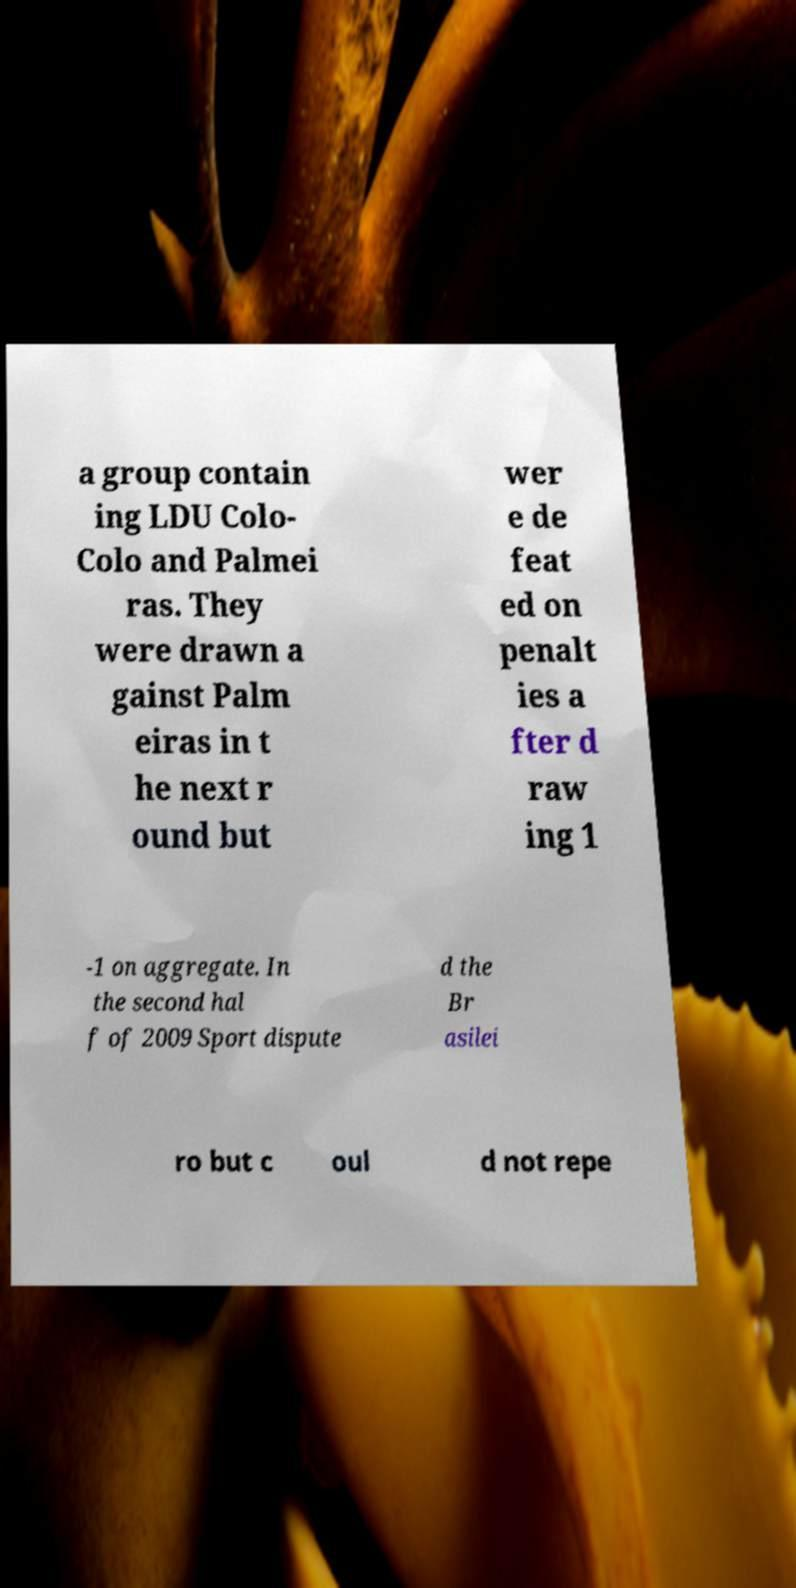There's text embedded in this image that I need extracted. Can you transcribe it verbatim? a group contain ing LDU Colo- Colo and Palmei ras. They were drawn a gainst Palm eiras in t he next r ound but wer e de feat ed on penalt ies a fter d raw ing 1 -1 on aggregate. In the second hal f of 2009 Sport dispute d the Br asilei ro but c oul d not repe 